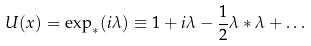<formula> <loc_0><loc_0><loc_500><loc_500>U ( x ) = \exp _ { * } ( i \lambda ) \equiv 1 + i \lambda - \frac { 1 } { 2 } \lambda * \lambda + \dots</formula> 